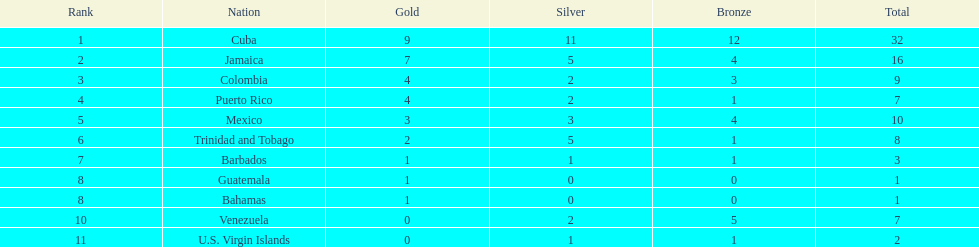Largest medal differential between countries 31. Could you help me parse every detail presented in this table? {'header': ['Rank', 'Nation', 'Gold', 'Silver', 'Bronze', 'Total'], 'rows': [['1', 'Cuba', '9', '11', '12', '32'], ['2', 'Jamaica', '7', '5', '4', '16'], ['3', 'Colombia', '4', '2', '3', '9'], ['4', 'Puerto Rico', '4', '2', '1', '7'], ['5', 'Mexico', '3', '3', '4', '10'], ['6', 'Trinidad and Tobago', '2', '5', '1', '8'], ['7', 'Barbados', '1', '1', '1', '3'], ['8', 'Guatemala', '1', '0', '0', '1'], ['8', 'Bahamas', '1', '0', '0', '1'], ['10', 'Venezuela', '0', '2', '5', '7'], ['11', 'U.S. Virgin Islands', '0', '1', '1', '2']]} 